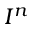<formula> <loc_0><loc_0><loc_500><loc_500>I ^ { n }</formula> 